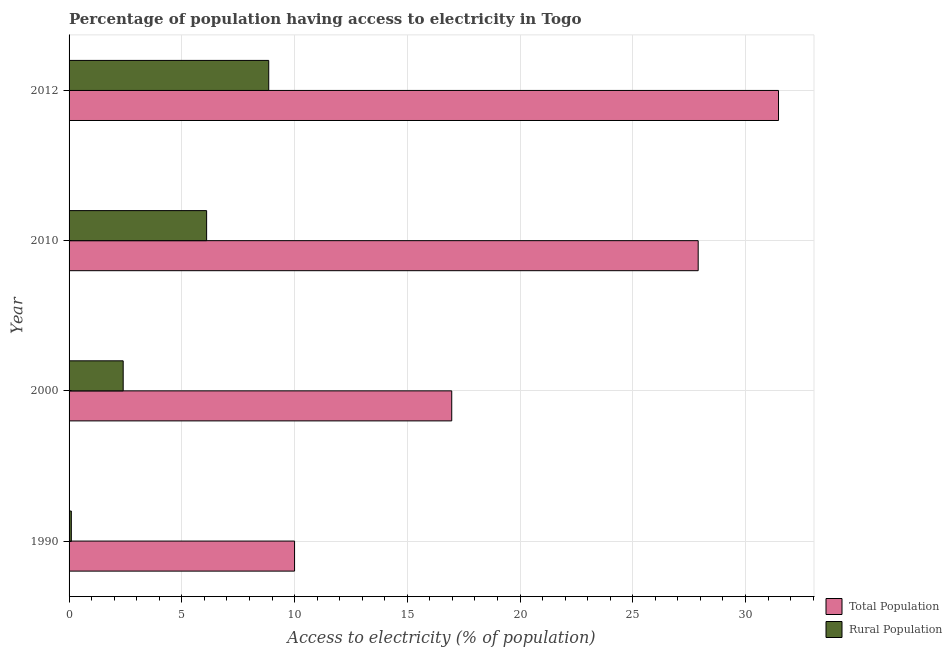How many different coloured bars are there?
Provide a succinct answer. 2. Are the number of bars per tick equal to the number of legend labels?
Your answer should be compact. Yes. Are the number of bars on each tick of the Y-axis equal?
Ensure brevity in your answer.  Yes. How many bars are there on the 1st tick from the top?
Provide a short and direct response. 2. What is the percentage of population having access to electricity in 1990?
Ensure brevity in your answer.  10. Across all years, what is the maximum percentage of rural population having access to electricity?
Keep it short and to the point. 8.85. In which year was the percentage of rural population having access to electricity maximum?
Your response must be concise. 2012. In which year was the percentage of rural population having access to electricity minimum?
Offer a terse response. 1990. What is the total percentage of rural population having access to electricity in the graph?
Offer a very short reply. 17.45. What is the difference between the percentage of rural population having access to electricity in 2000 and that in 2010?
Offer a terse response. -3.7. What is the difference between the percentage of rural population having access to electricity in 2010 and the percentage of population having access to electricity in 1990?
Ensure brevity in your answer.  -3.9. What is the average percentage of population having access to electricity per year?
Provide a short and direct response. 21.58. In how many years, is the percentage of population having access to electricity greater than 32 %?
Offer a very short reply. 0. What is the ratio of the percentage of population having access to electricity in 2010 to that in 2012?
Give a very brief answer. 0.89. Is the percentage of population having access to electricity in 1990 less than that in 2012?
Offer a terse response. Yes. Is the difference between the percentage of rural population having access to electricity in 1990 and 2012 greater than the difference between the percentage of population having access to electricity in 1990 and 2012?
Make the answer very short. Yes. What is the difference between the highest and the second highest percentage of population having access to electricity?
Your answer should be compact. 3.56. What is the difference between the highest and the lowest percentage of population having access to electricity?
Keep it short and to the point. 21.46. Is the sum of the percentage of population having access to electricity in 2000 and 2012 greater than the maximum percentage of rural population having access to electricity across all years?
Give a very brief answer. Yes. What does the 2nd bar from the top in 2000 represents?
Keep it short and to the point. Total Population. What does the 2nd bar from the bottom in 2000 represents?
Your answer should be very brief. Rural Population. How many bars are there?
Give a very brief answer. 8. Are all the bars in the graph horizontal?
Your answer should be compact. Yes. How many years are there in the graph?
Provide a succinct answer. 4. What is the difference between two consecutive major ticks on the X-axis?
Offer a very short reply. 5. Where does the legend appear in the graph?
Provide a succinct answer. Bottom right. What is the title of the graph?
Your response must be concise. Percentage of population having access to electricity in Togo. Does "Domestic Liabilities" appear as one of the legend labels in the graph?
Offer a terse response. No. What is the label or title of the X-axis?
Offer a very short reply. Access to electricity (% of population). What is the Access to electricity (% of population) of Total Population in 1990?
Offer a very short reply. 10. What is the Access to electricity (% of population) of Rural Population in 1990?
Provide a succinct answer. 0.1. What is the Access to electricity (% of population) of Total Population in 2000?
Offer a very short reply. 16.97. What is the Access to electricity (% of population) of Rural Population in 2000?
Your answer should be compact. 2.4. What is the Access to electricity (% of population) in Total Population in 2010?
Your answer should be very brief. 27.9. What is the Access to electricity (% of population) of Rural Population in 2010?
Make the answer very short. 6.1. What is the Access to electricity (% of population) of Total Population in 2012?
Ensure brevity in your answer.  31.46. What is the Access to electricity (% of population) of Rural Population in 2012?
Your answer should be compact. 8.85. Across all years, what is the maximum Access to electricity (% of population) in Total Population?
Ensure brevity in your answer.  31.46. Across all years, what is the maximum Access to electricity (% of population) in Rural Population?
Offer a terse response. 8.85. Across all years, what is the minimum Access to electricity (% of population) of Total Population?
Keep it short and to the point. 10. Across all years, what is the minimum Access to electricity (% of population) of Rural Population?
Give a very brief answer. 0.1. What is the total Access to electricity (% of population) of Total Population in the graph?
Your answer should be very brief. 86.33. What is the total Access to electricity (% of population) of Rural Population in the graph?
Give a very brief answer. 17.45. What is the difference between the Access to electricity (% of population) in Total Population in 1990 and that in 2000?
Give a very brief answer. -6.97. What is the difference between the Access to electricity (% of population) in Rural Population in 1990 and that in 2000?
Provide a succinct answer. -2.3. What is the difference between the Access to electricity (% of population) in Total Population in 1990 and that in 2010?
Ensure brevity in your answer.  -17.9. What is the difference between the Access to electricity (% of population) in Total Population in 1990 and that in 2012?
Provide a succinct answer. -21.46. What is the difference between the Access to electricity (% of population) in Rural Population in 1990 and that in 2012?
Offer a terse response. -8.75. What is the difference between the Access to electricity (% of population) in Total Population in 2000 and that in 2010?
Your answer should be compact. -10.93. What is the difference between the Access to electricity (% of population) in Rural Population in 2000 and that in 2010?
Your answer should be compact. -3.7. What is the difference between the Access to electricity (% of population) in Total Population in 2000 and that in 2012?
Keep it short and to the point. -14.49. What is the difference between the Access to electricity (% of population) of Rural Population in 2000 and that in 2012?
Provide a succinct answer. -6.45. What is the difference between the Access to electricity (% of population) of Total Population in 2010 and that in 2012?
Keep it short and to the point. -3.56. What is the difference between the Access to electricity (% of population) in Rural Population in 2010 and that in 2012?
Offer a terse response. -2.75. What is the difference between the Access to electricity (% of population) in Total Population in 1990 and the Access to electricity (% of population) in Rural Population in 2012?
Provide a short and direct response. 1.15. What is the difference between the Access to electricity (% of population) in Total Population in 2000 and the Access to electricity (% of population) in Rural Population in 2010?
Offer a very short reply. 10.87. What is the difference between the Access to electricity (% of population) in Total Population in 2000 and the Access to electricity (% of population) in Rural Population in 2012?
Ensure brevity in your answer.  8.12. What is the difference between the Access to electricity (% of population) in Total Population in 2010 and the Access to electricity (% of population) in Rural Population in 2012?
Ensure brevity in your answer.  19.05. What is the average Access to electricity (% of population) of Total Population per year?
Keep it short and to the point. 21.58. What is the average Access to electricity (% of population) in Rural Population per year?
Offer a very short reply. 4.36. In the year 1990, what is the difference between the Access to electricity (% of population) in Total Population and Access to electricity (% of population) in Rural Population?
Your response must be concise. 9.9. In the year 2000, what is the difference between the Access to electricity (% of population) in Total Population and Access to electricity (% of population) in Rural Population?
Your answer should be compact. 14.57. In the year 2010, what is the difference between the Access to electricity (% of population) in Total Population and Access to electricity (% of population) in Rural Population?
Keep it short and to the point. 21.8. In the year 2012, what is the difference between the Access to electricity (% of population) in Total Population and Access to electricity (% of population) in Rural Population?
Offer a terse response. 22.61. What is the ratio of the Access to electricity (% of population) of Total Population in 1990 to that in 2000?
Give a very brief answer. 0.59. What is the ratio of the Access to electricity (% of population) of Rural Population in 1990 to that in 2000?
Provide a succinct answer. 0.04. What is the ratio of the Access to electricity (% of population) of Total Population in 1990 to that in 2010?
Your response must be concise. 0.36. What is the ratio of the Access to electricity (% of population) of Rural Population in 1990 to that in 2010?
Offer a very short reply. 0.02. What is the ratio of the Access to electricity (% of population) of Total Population in 1990 to that in 2012?
Provide a succinct answer. 0.32. What is the ratio of the Access to electricity (% of population) in Rural Population in 1990 to that in 2012?
Offer a very short reply. 0.01. What is the ratio of the Access to electricity (% of population) of Total Population in 2000 to that in 2010?
Ensure brevity in your answer.  0.61. What is the ratio of the Access to electricity (% of population) in Rural Population in 2000 to that in 2010?
Give a very brief answer. 0.39. What is the ratio of the Access to electricity (% of population) of Total Population in 2000 to that in 2012?
Your response must be concise. 0.54. What is the ratio of the Access to electricity (% of population) in Rural Population in 2000 to that in 2012?
Your answer should be compact. 0.27. What is the ratio of the Access to electricity (% of population) of Total Population in 2010 to that in 2012?
Your answer should be very brief. 0.89. What is the ratio of the Access to electricity (% of population) of Rural Population in 2010 to that in 2012?
Make the answer very short. 0.69. What is the difference between the highest and the second highest Access to electricity (% of population) of Total Population?
Provide a short and direct response. 3.56. What is the difference between the highest and the second highest Access to electricity (% of population) in Rural Population?
Make the answer very short. 2.75. What is the difference between the highest and the lowest Access to electricity (% of population) of Total Population?
Ensure brevity in your answer.  21.46. What is the difference between the highest and the lowest Access to electricity (% of population) in Rural Population?
Your answer should be very brief. 8.75. 